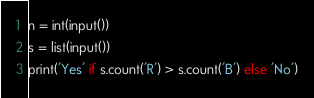<code> <loc_0><loc_0><loc_500><loc_500><_Python_>n = int(input())
s = list(input())
print('Yes' if s.count('R') > s.count('B') else 'No')</code> 